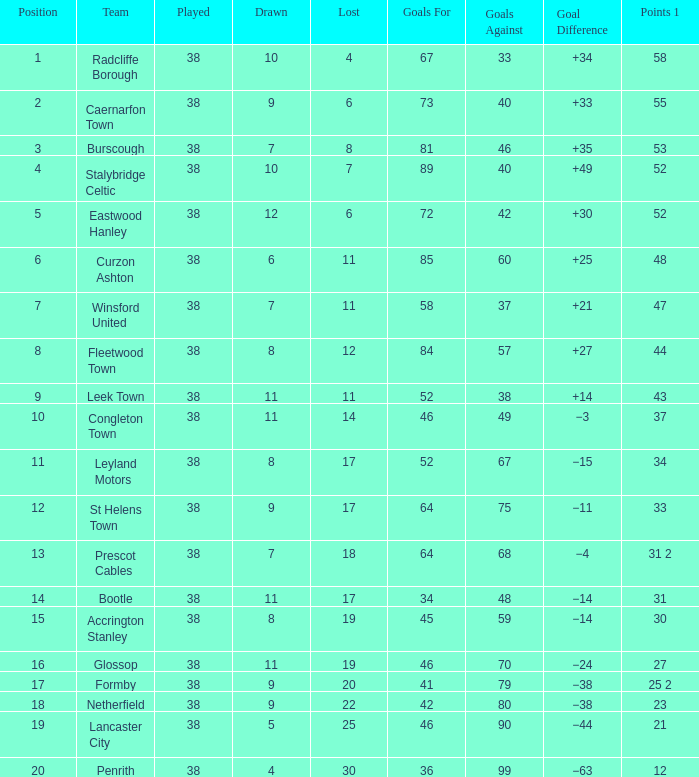What is the ranking for caernarfon town when they have a loss of 6? 2.0. 